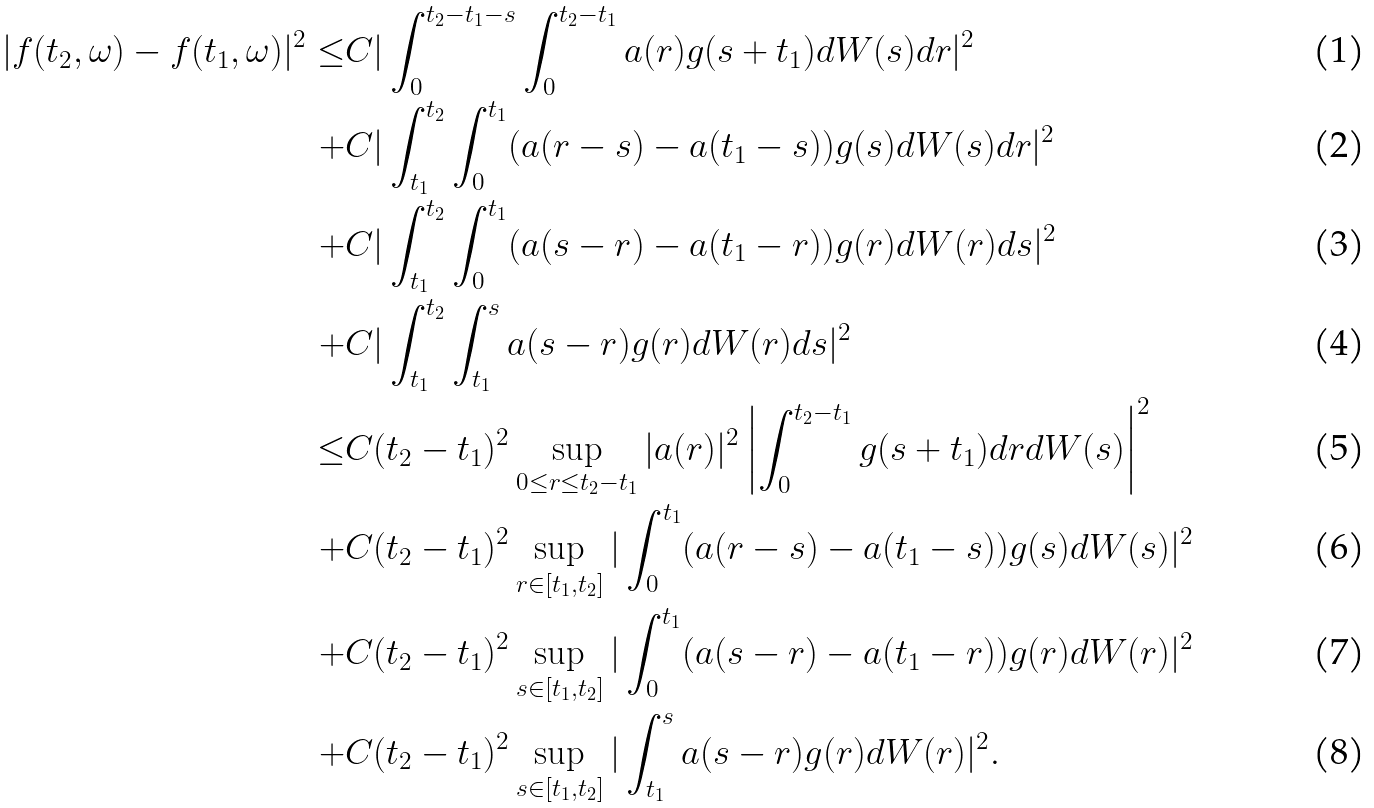Convert formula to latex. <formula><loc_0><loc_0><loc_500><loc_500>| f ( t _ { 2 } , \omega ) - f ( t _ { 1 } , \omega ) | ^ { 2 } \leq & C | \int _ { 0 } ^ { t _ { 2 } - t _ { 1 } - s } \int _ { 0 } ^ { t _ { 2 } - t _ { 1 } } a ( r ) g ( s + t _ { 1 } ) d W ( s ) d r | ^ { 2 } \\ + & C | \int _ { t _ { 1 } } ^ { t _ { 2 } } \int _ { 0 } ^ { t _ { 1 } } ( a ( r - s ) - a ( t _ { 1 } - s ) ) g ( s ) d W ( s ) d r | ^ { 2 } \\ + & C | \int _ { t _ { 1 } } ^ { t _ { 2 } } \int _ { 0 } ^ { t _ { 1 } } ( a ( s - r ) - a ( t _ { 1 } - r ) ) g ( r ) d W ( r ) d s | ^ { 2 } \\ + & C | \int _ { t _ { 1 } } ^ { t _ { 2 } } \int _ { t _ { 1 } } ^ { s } a ( s - r ) g ( r ) d W ( r ) d s | ^ { 2 } \\ \leq & C ( t _ { 2 } - t _ { 1 } ) ^ { 2 } \sup _ { 0 \leq r \leq t _ { 2 } - t _ { 1 } } | a ( r ) | ^ { 2 } \left | \int _ { 0 } ^ { t _ { 2 } - t _ { 1 } } g ( s + t _ { 1 } ) d r d W ( s ) \right | ^ { 2 } \\ + & C ( t _ { 2 } - t _ { 1 } ) ^ { 2 } \sup _ { r \in [ t _ { 1 } , t _ { 2 } ] } | \int _ { 0 } ^ { t _ { 1 } } ( a ( r - s ) - a ( t _ { 1 } - s ) ) g ( s ) d W ( s ) | ^ { 2 } \\ + & C ( t _ { 2 } - t _ { 1 } ) ^ { 2 } \sup _ { s \in [ t _ { 1 } , t _ { 2 } ] } | \int _ { 0 } ^ { t _ { 1 } } ( a ( s - r ) - a ( t _ { 1 } - r ) ) g ( r ) d W ( r ) | ^ { 2 } \\ + & C ( t _ { 2 } - t _ { 1 } ) ^ { 2 } \sup _ { s \in [ t _ { 1 } , t _ { 2 } ] } | \int _ { t _ { 1 } } ^ { s } a ( s - r ) g ( r ) d W ( r ) | ^ { 2 } .</formula> 